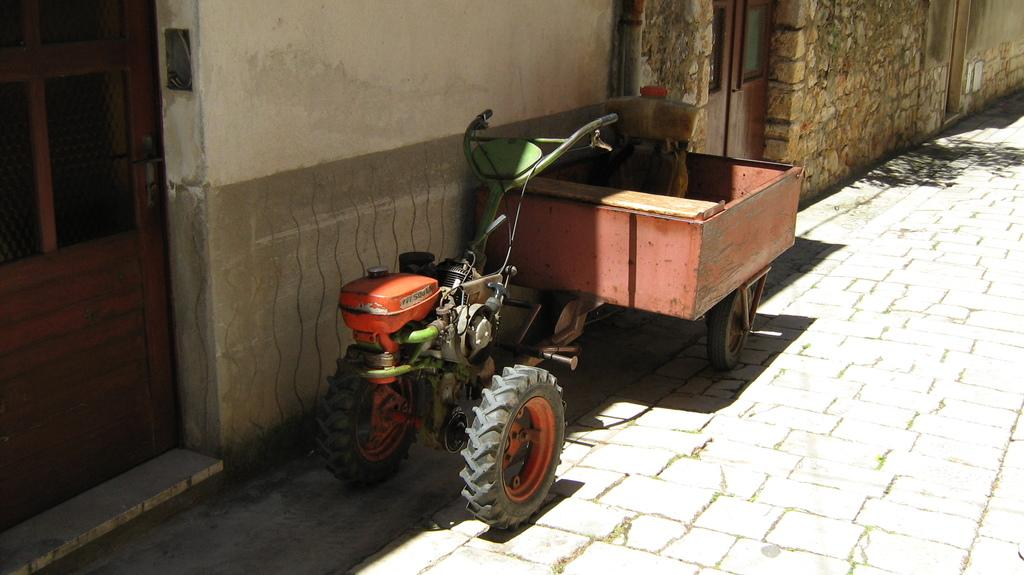What is the main subject of the image? The main subject of the image is a tractor. What is attached to the tractor? The tractor has a trolley attached to it. Where is the tractor and trolley located? They are on a road surface. What is located near the tractor? There is a house beside the tractor. What feature of the house is mentioned? The house has doors. What type of vegetable is growing on the roof of the house in the image? There is no vegetable growing on the roof of the house in the image. Can you tell me how many astronauts are walking around the tractor in the image? There are no astronauts or any space-related elements present in the image. 